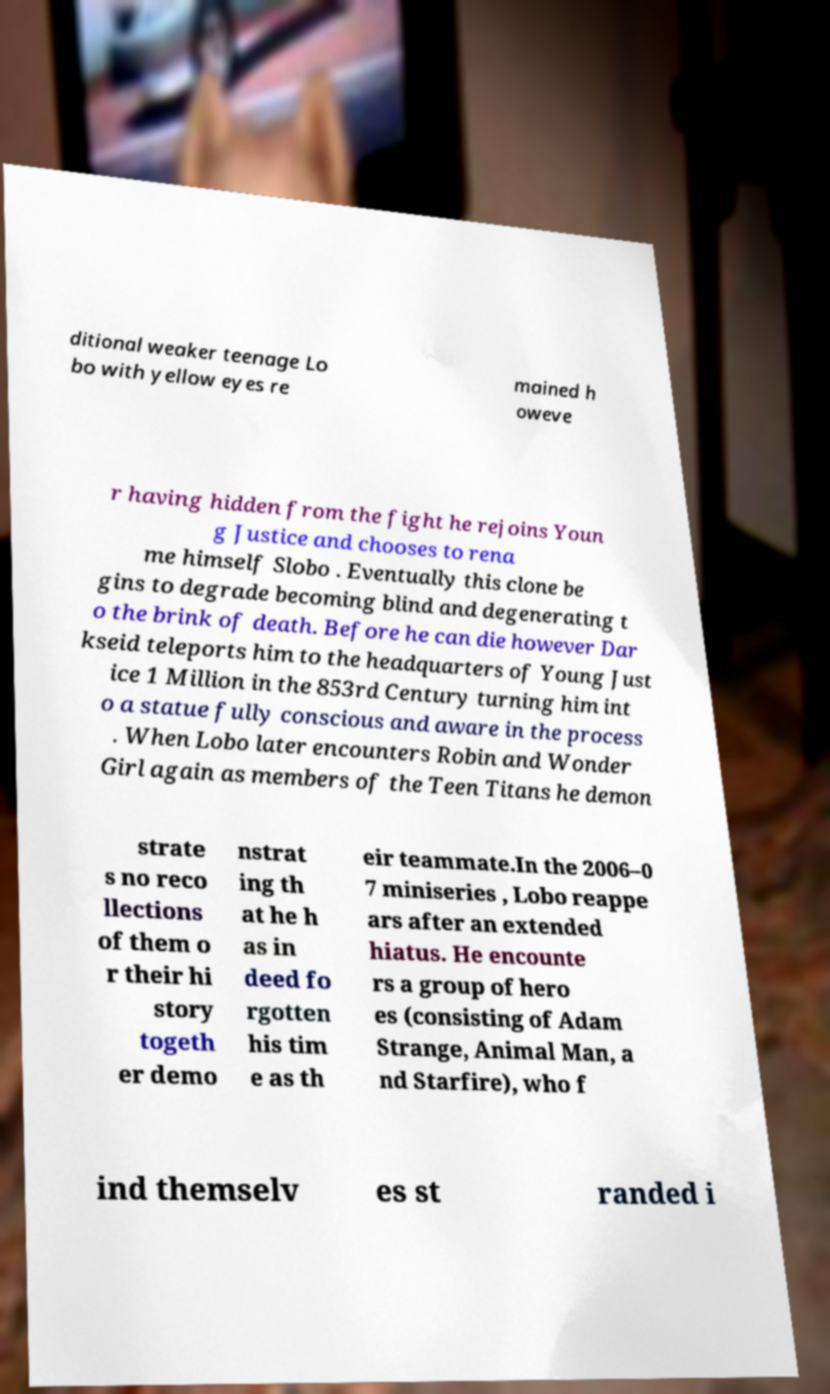Please read and relay the text visible in this image. What does it say? ditional weaker teenage Lo bo with yellow eyes re mained h oweve r having hidden from the fight he rejoins Youn g Justice and chooses to rena me himself Slobo . Eventually this clone be gins to degrade becoming blind and degenerating t o the brink of death. Before he can die however Dar kseid teleports him to the headquarters of Young Just ice 1 Million in the 853rd Century turning him int o a statue fully conscious and aware in the process . When Lobo later encounters Robin and Wonder Girl again as members of the Teen Titans he demon strate s no reco llections of them o r their hi story togeth er demo nstrat ing th at he h as in deed fo rgotten his tim e as th eir teammate.In the 2006–0 7 miniseries , Lobo reappe ars after an extended hiatus. He encounte rs a group of hero es (consisting of Adam Strange, Animal Man, a nd Starfire), who f ind themselv es st randed i 